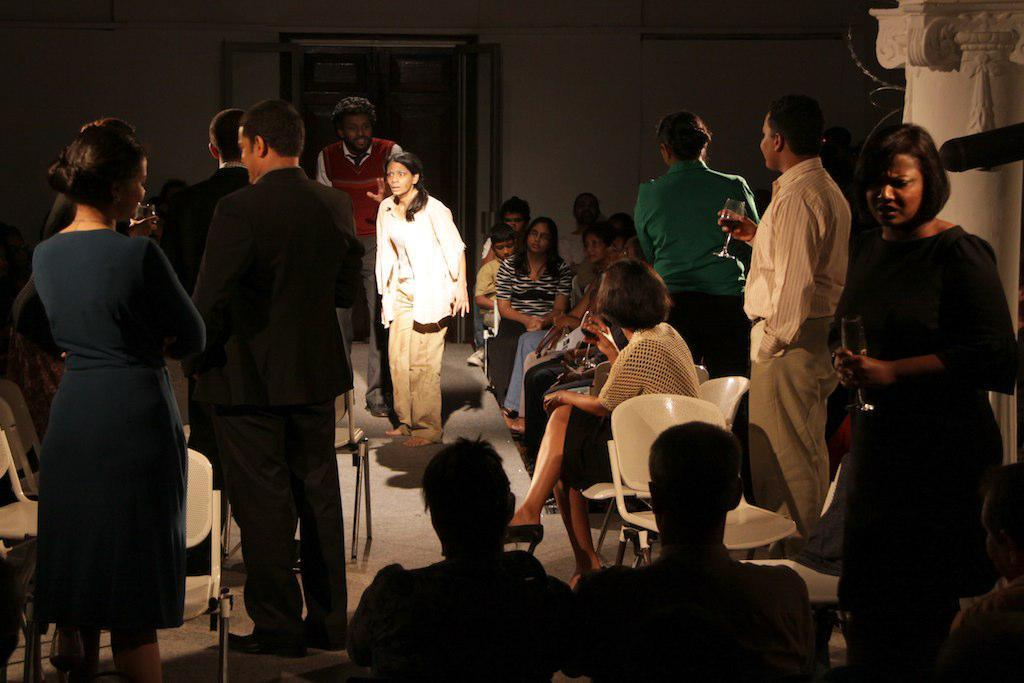What are the persons in the image doing? There are persons sitting on chairs and standing in the image. Can you describe the background of the image? In the background, there are empty chairs, doors, a wall, and other objects. How many chairs can be seen in the image? There are chairs for the persons sitting and empty chairs in the background, so there are at least two chairs visible. What type of insurance is being discussed by the persons in the image? There is no indication in the image that the persons are discussing insurance. 